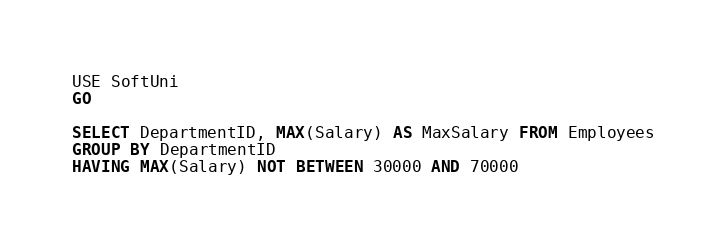<code> <loc_0><loc_0><loc_500><loc_500><_SQL_>USE SoftUni
GO

SELECT DepartmentID, MAX(Salary) AS MaxSalary FROM Employees
GROUP BY DepartmentID
HAVING MAX(Salary) NOT BETWEEN 30000 AND 70000</code> 